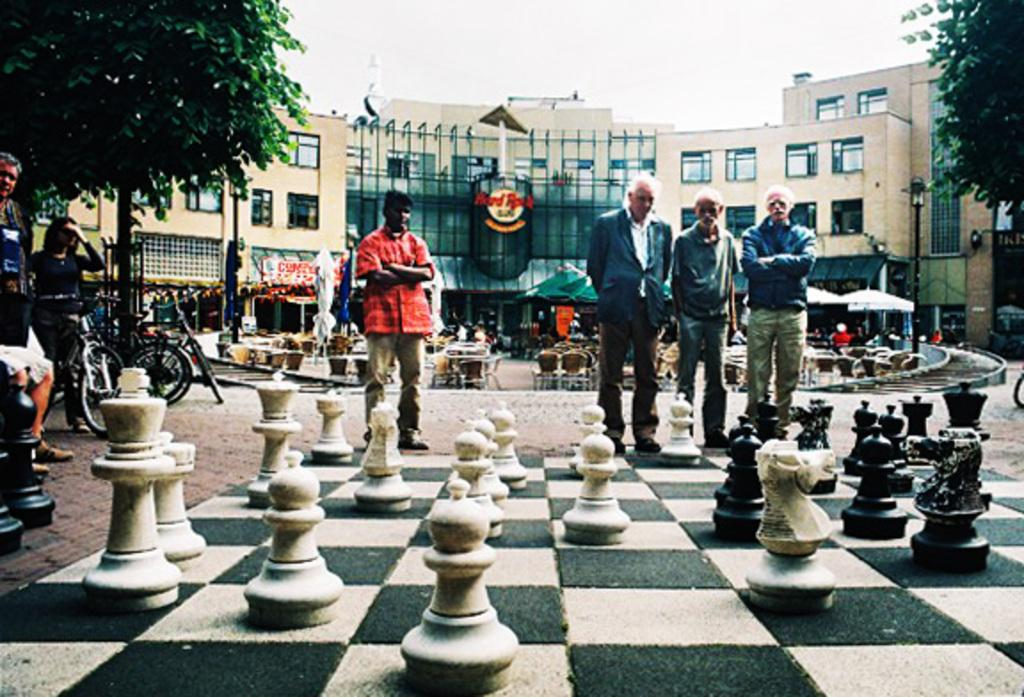Provide a one-sentence caption for the provided image. A group of men standing in front of  Hard Rock Cafe building. 